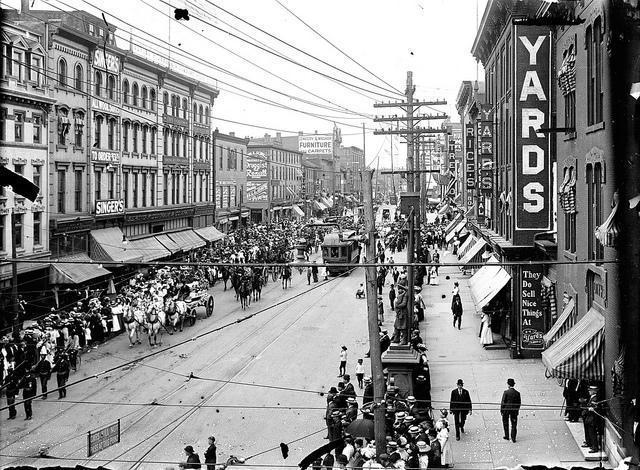How many apples are there?
Give a very brief answer. 0. 